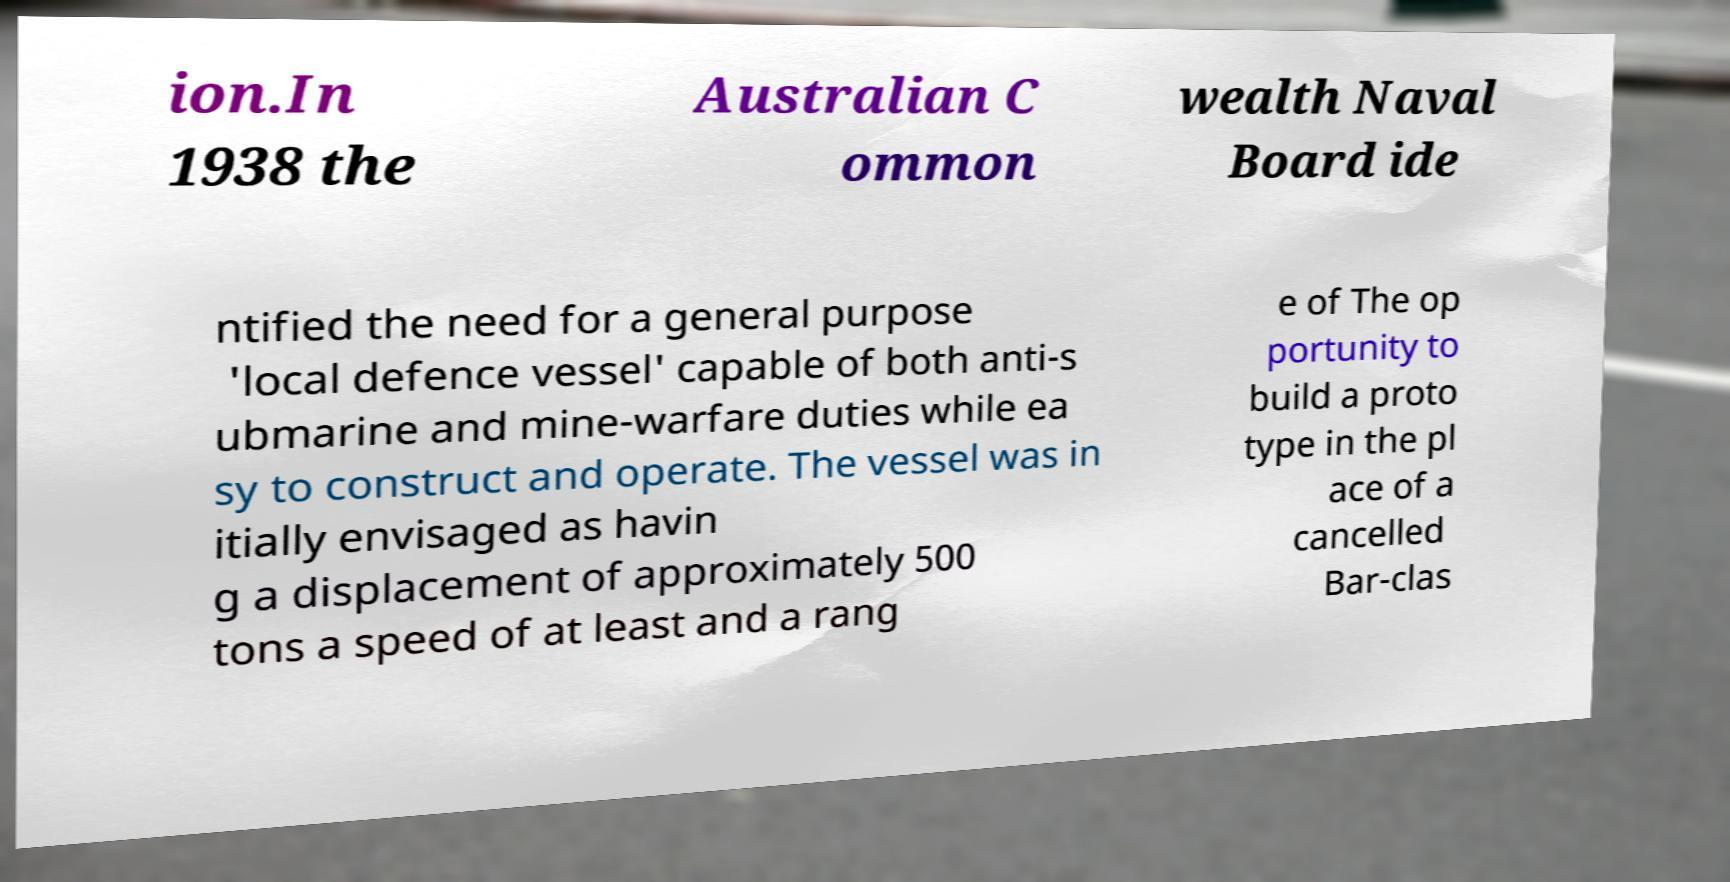I need the written content from this picture converted into text. Can you do that? ion.In 1938 the Australian C ommon wealth Naval Board ide ntified the need for a general purpose 'local defence vessel' capable of both anti-s ubmarine and mine-warfare duties while ea sy to construct and operate. The vessel was in itially envisaged as havin g a displacement of approximately 500 tons a speed of at least and a rang e of The op portunity to build a proto type in the pl ace of a cancelled Bar-clas 